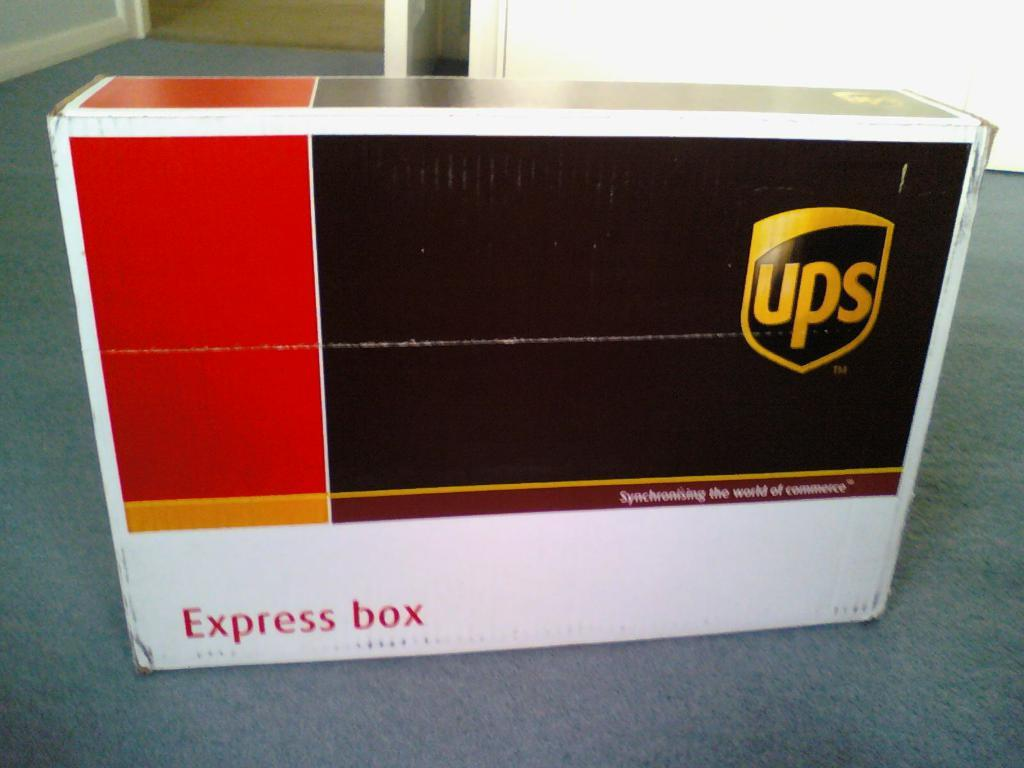<image>
Present a compact description of the photo's key features. A brown, red and white ups box with the words express box written below. 